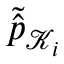<formula> <loc_0><loc_0><loc_500><loc_500>\tilde { \widehat { p } } _ { \mathcal { K } _ { i } }</formula> 